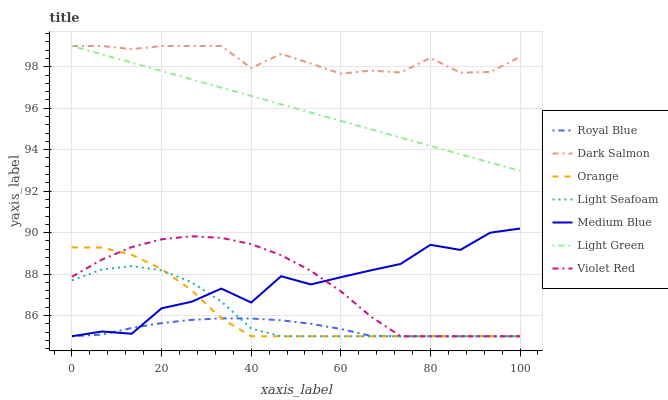Does Royal Blue have the minimum area under the curve?
Answer yes or no. Yes. Does Dark Salmon have the maximum area under the curve?
Answer yes or no. Yes. Does Medium Blue have the minimum area under the curve?
Answer yes or no. No. Does Medium Blue have the maximum area under the curve?
Answer yes or no. No. Is Light Green the smoothest?
Answer yes or no. Yes. Is Medium Blue the roughest?
Answer yes or no. Yes. Is Dark Salmon the smoothest?
Answer yes or no. No. Is Dark Salmon the roughest?
Answer yes or no. No. Does Violet Red have the lowest value?
Answer yes or no. Yes. Does Dark Salmon have the lowest value?
Answer yes or no. No. Does Light Green have the highest value?
Answer yes or no. Yes. Does Medium Blue have the highest value?
Answer yes or no. No. Is Medium Blue less than Light Green?
Answer yes or no. Yes. Is Dark Salmon greater than Orange?
Answer yes or no. Yes. Does Medium Blue intersect Light Seafoam?
Answer yes or no. Yes. Is Medium Blue less than Light Seafoam?
Answer yes or no. No. Is Medium Blue greater than Light Seafoam?
Answer yes or no. No. Does Medium Blue intersect Light Green?
Answer yes or no. No. 